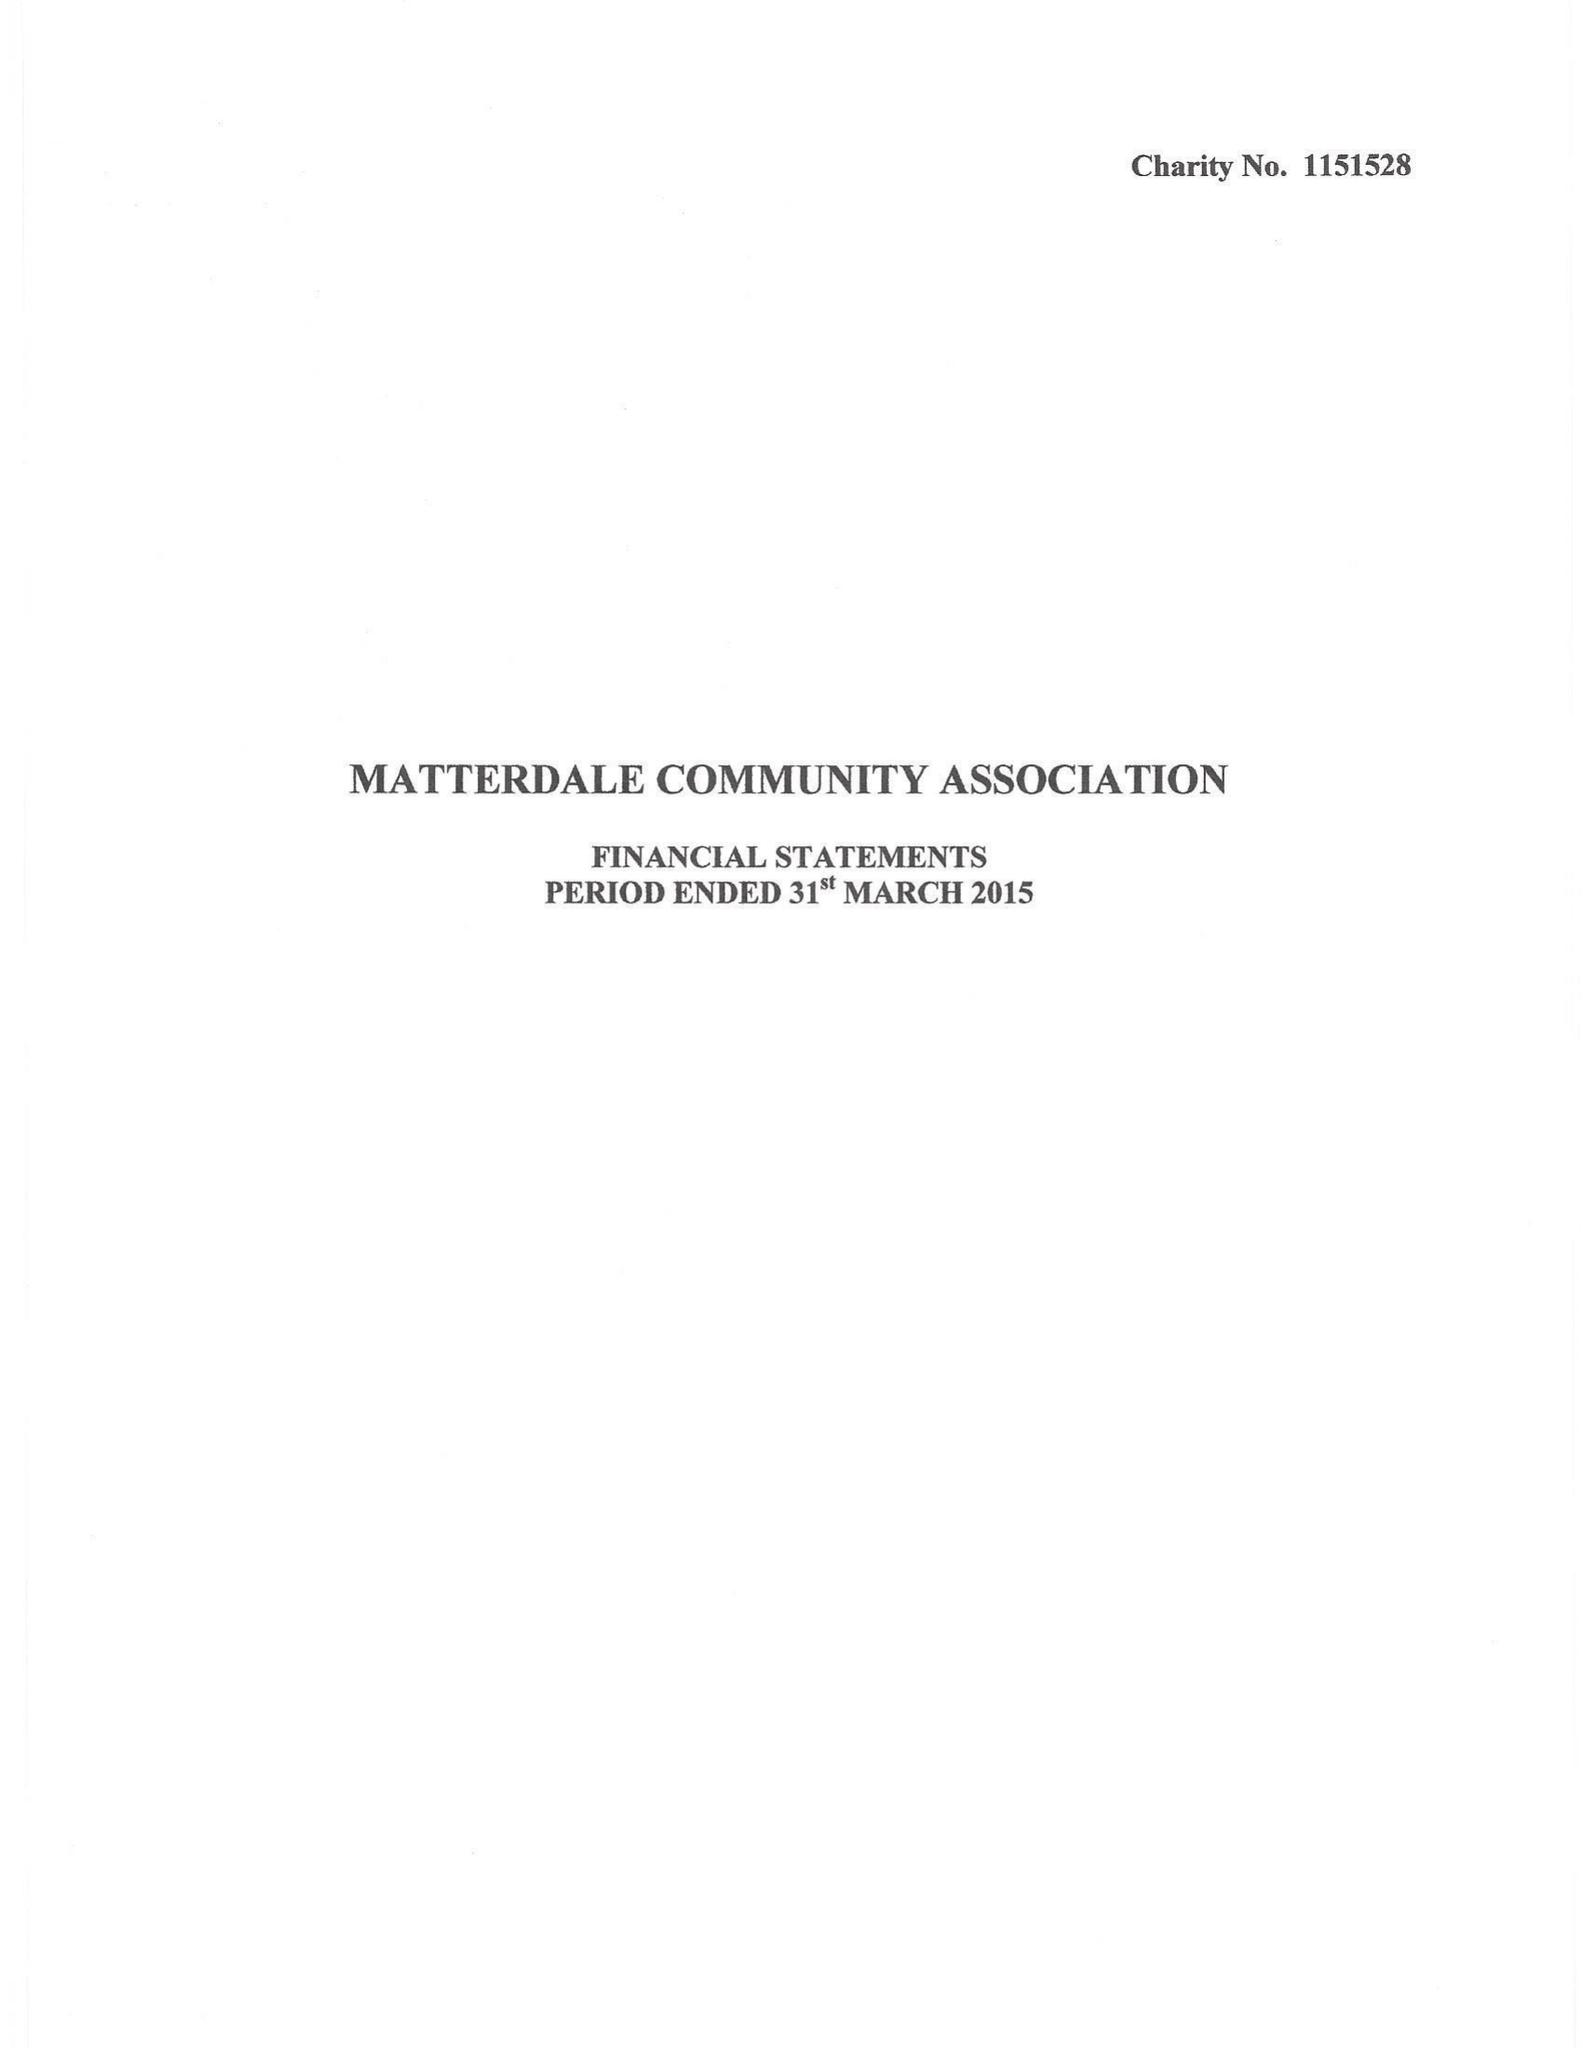What is the value for the address__post_town?
Answer the question using a single word or phrase. PENRITH 